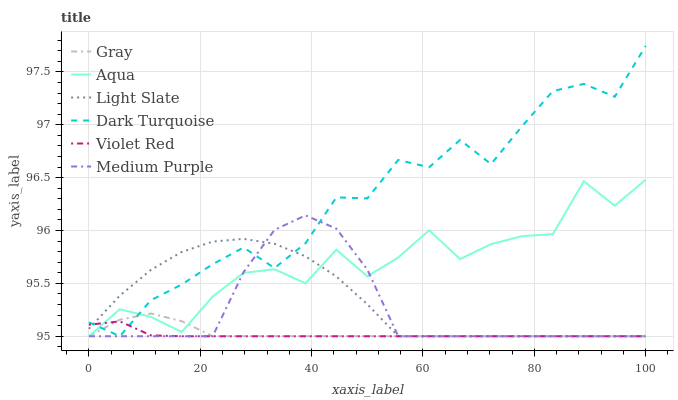Does Violet Red have the minimum area under the curve?
Answer yes or no. Yes. Does Dark Turquoise have the maximum area under the curve?
Answer yes or no. Yes. Does Light Slate have the minimum area under the curve?
Answer yes or no. No. Does Light Slate have the maximum area under the curve?
Answer yes or no. No. Is Violet Red the smoothest?
Answer yes or no. Yes. Is Aqua the roughest?
Answer yes or no. Yes. Is Light Slate the smoothest?
Answer yes or no. No. Is Light Slate the roughest?
Answer yes or no. No. Does Gray have the lowest value?
Answer yes or no. Yes. Does Dark Turquoise have the highest value?
Answer yes or no. Yes. Does Light Slate have the highest value?
Answer yes or no. No. Does Light Slate intersect Medium Purple?
Answer yes or no. Yes. Is Light Slate less than Medium Purple?
Answer yes or no. No. Is Light Slate greater than Medium Purple?
Answer yes or no. No. 